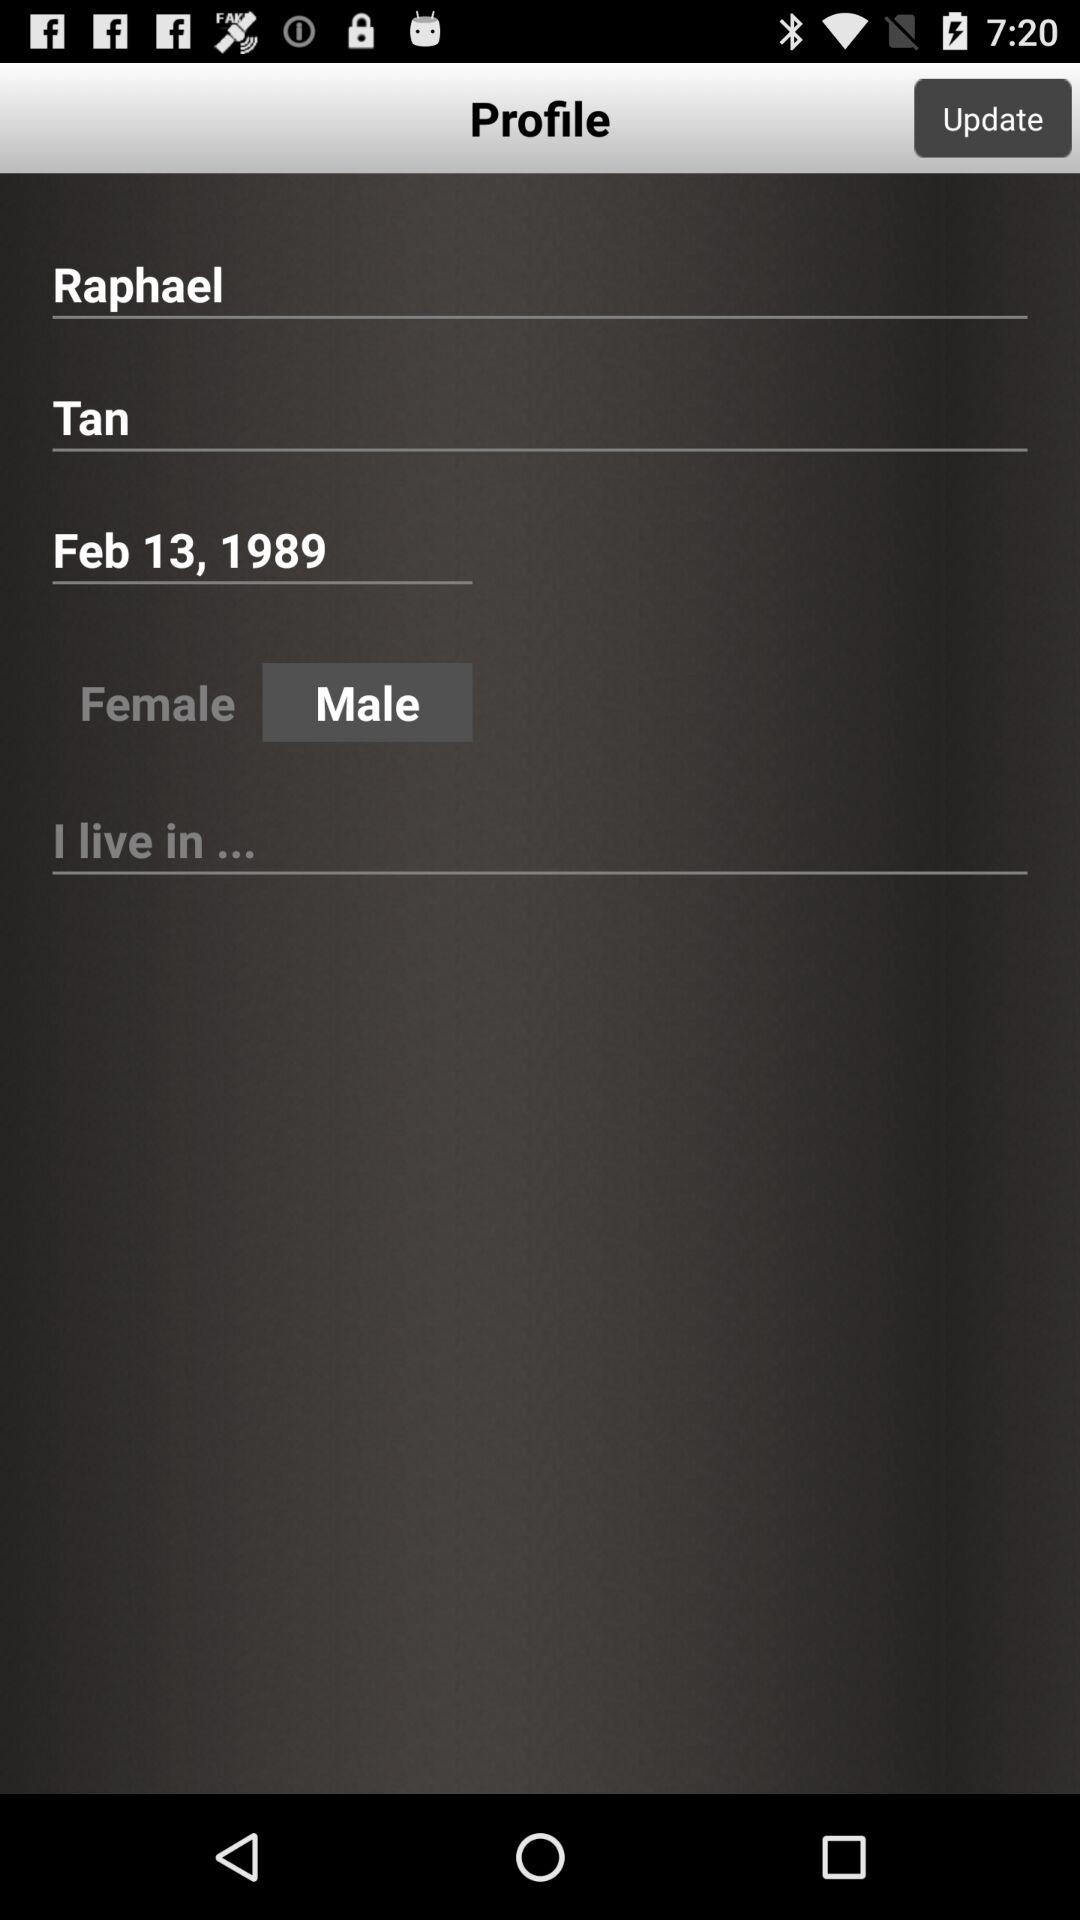What is the date of birth of the user? The date of birth of the user is February 13, 1989. 